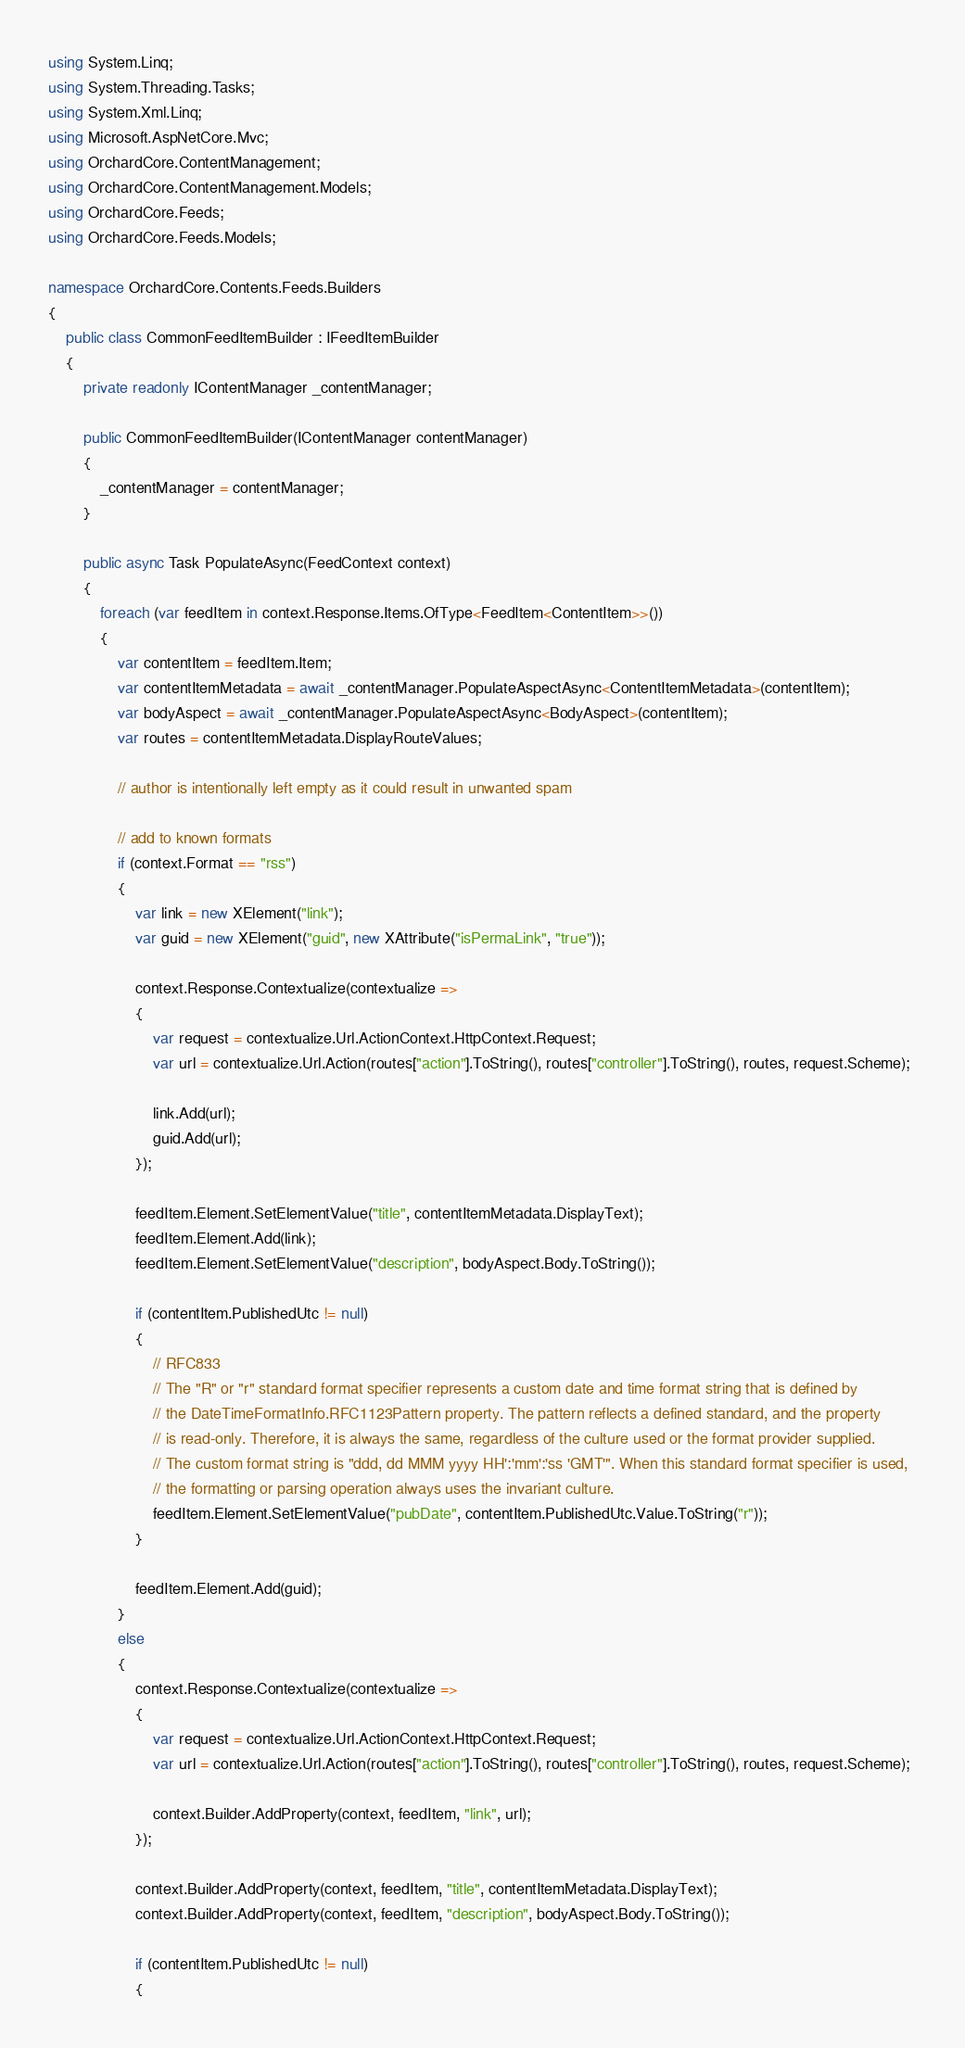Convert code to text. <code><loc_0><loc_0><loc_500><loc_500><_C#_>using System.Linq;
using System.Threading.Tasks;
using System.Xml.Linq;
using Microsoft.AspNetCore.Mvc;
using OrchardCore.ContentManagement;
using OrchardCore.ContentManagement.Models;
using OrchardCore.Feeds;
using OrchardCore.Feeds.Models;

namespace OrchardCore.Contents.Feeds.Builders
{
    public class CommonFeedItemBuilder : IFeedItemBuilder
    {
        private readonly IContentManager _contentManager;

        public CommonFeedItemBuilder(IContentManager contentManager)
        {
            _contentManager = contentManager;
        }

        public async Task PopulateAsync(FeedContext context)
        {
            foreach (var feedItem in context.Response.Items.OfType<FeedItem<ContentItem>>())
            {
                var contentItem = feedItem.Item;
                var contentItemMetadata = await _contentManager.PopulateAspectAsync<ContentItemMetadata>(contentItem);
                var bodyAspect = await _contentManager.PopulateAspectAsync<BodyAspect>(contentItem);
                var routes = contentItemMetadata.DisplayRouteValues;

                // author is intentionally left empty as it could result in unwanted spam

                // add to known formats
                if (context.Format == "rss")
                {
                    var link = new XElement("link");
                    var guid = new XElement("guid", new XAttribute("isPermaLink", "true"));

                    context.Response.Contextualize(contextualize =>
                    {
                        var request = contextualize.Url.ActionContext.HttpContext.Request;
                        var url = contextualize.Url.Action(routes["action"].ToString(), routes["controller"].ToString(), routes, request.Scheme);

                        link.Add(url);
                        guid.Add(url);
                    });

                    feedItem.Element.SetElementValue("title", contentItemMetadata.DisplayText);
                    feedItem.Element.Add(link);
                    feedItem.Element.SetElementValue("description", bodyAspect.Body.ToString());

                    if (contentItem.PublishedUtc != null)
                    {
                        // RFC833 
                        // The "R" or "r" standard format specifier represents a custom date and time format string that is defined by 
                        // the DateTimeFormatInfo.RFC1123Pattern property. The pattern reflects a defined standard, and the property  
                        // is read-only. Therefore, it is always the same, regardless of the culture used or the format provider supplied.  
                        // The custom format string is "ddd, dd MMM yyyy HH':'mm':'ss 'GMT'". When this standard format specifier is used,  
                        // the formatting or parsing operation always uses the invariant culture. 
                        feedItem.Element.SetElementValue("pubDate", contentItem.PublishedUtc.Value.ToString("r"));
                    }

                    feedItem.Element.Add(guid);
                }
                else
                {
                    context.Response.Contextualize(contextualize =>
                    {
                        var request = contextualize.Url.ActionContext.HttpContext.Request;
                        var url = contextualize.Url.Action(routes["action"].ToString(), routes["controller"].ToString(), routes, request.Scheme);

                        context.Builder.AddProperty(context, feedItem, "link", url);
                    });

                    context.Builder.AddProperty(context, feedItem, "title", contentItemMetadata.DisplayText);
                    context.Builder.AddProperty(context, feedItem, "description", bodyAspect.Body.ToString());

                    if (contentItem.PublishedUtc != null)
                    {</code> 